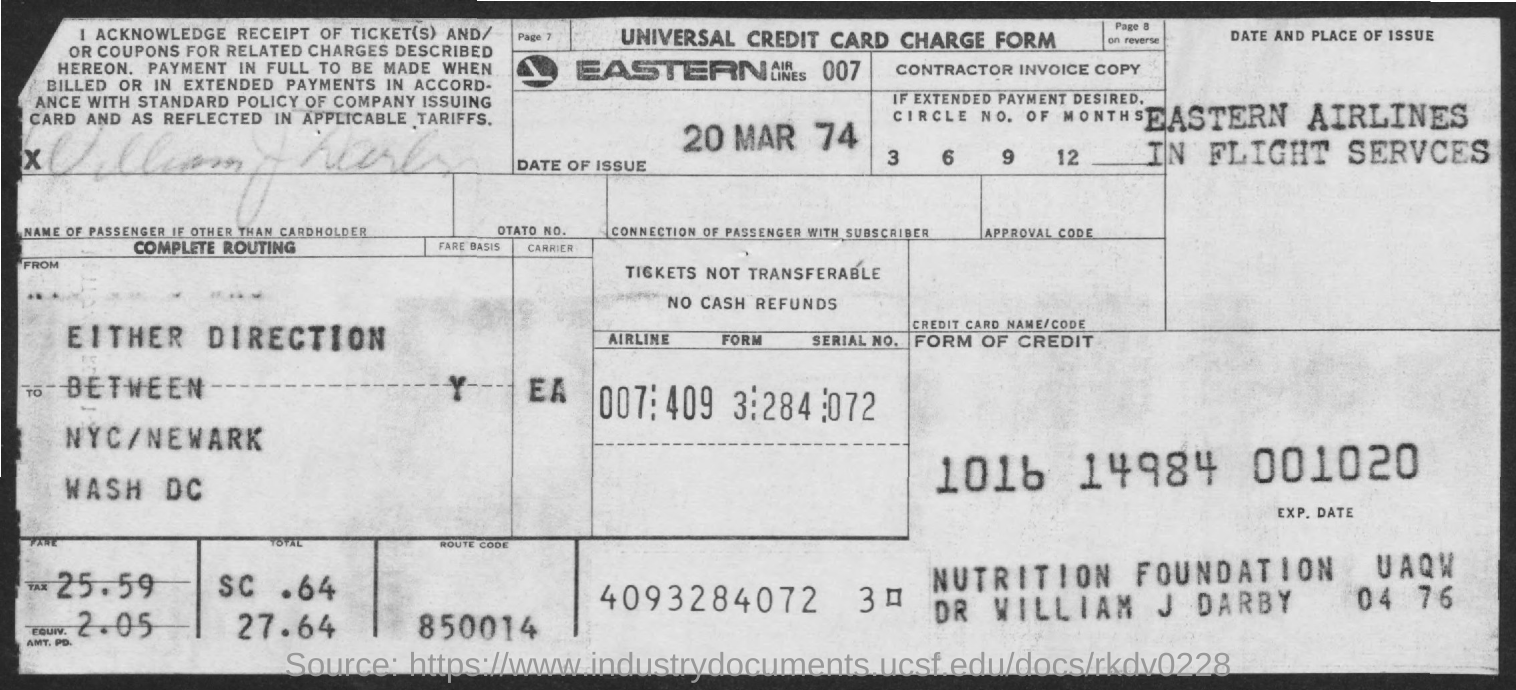What is the name of airlines
Keep it short and to the point. EASTERN AIRLINES 007. What is the route code mentioned ?
Offer a terse response. 850014. What is the date of issue
Ensure brevity in your answer.  20 MAR 74. 